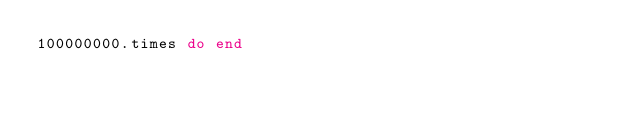<code> <loc_0><loc_0><loc_500><loc_500><_Ruby_>100000000.times do end</code> 